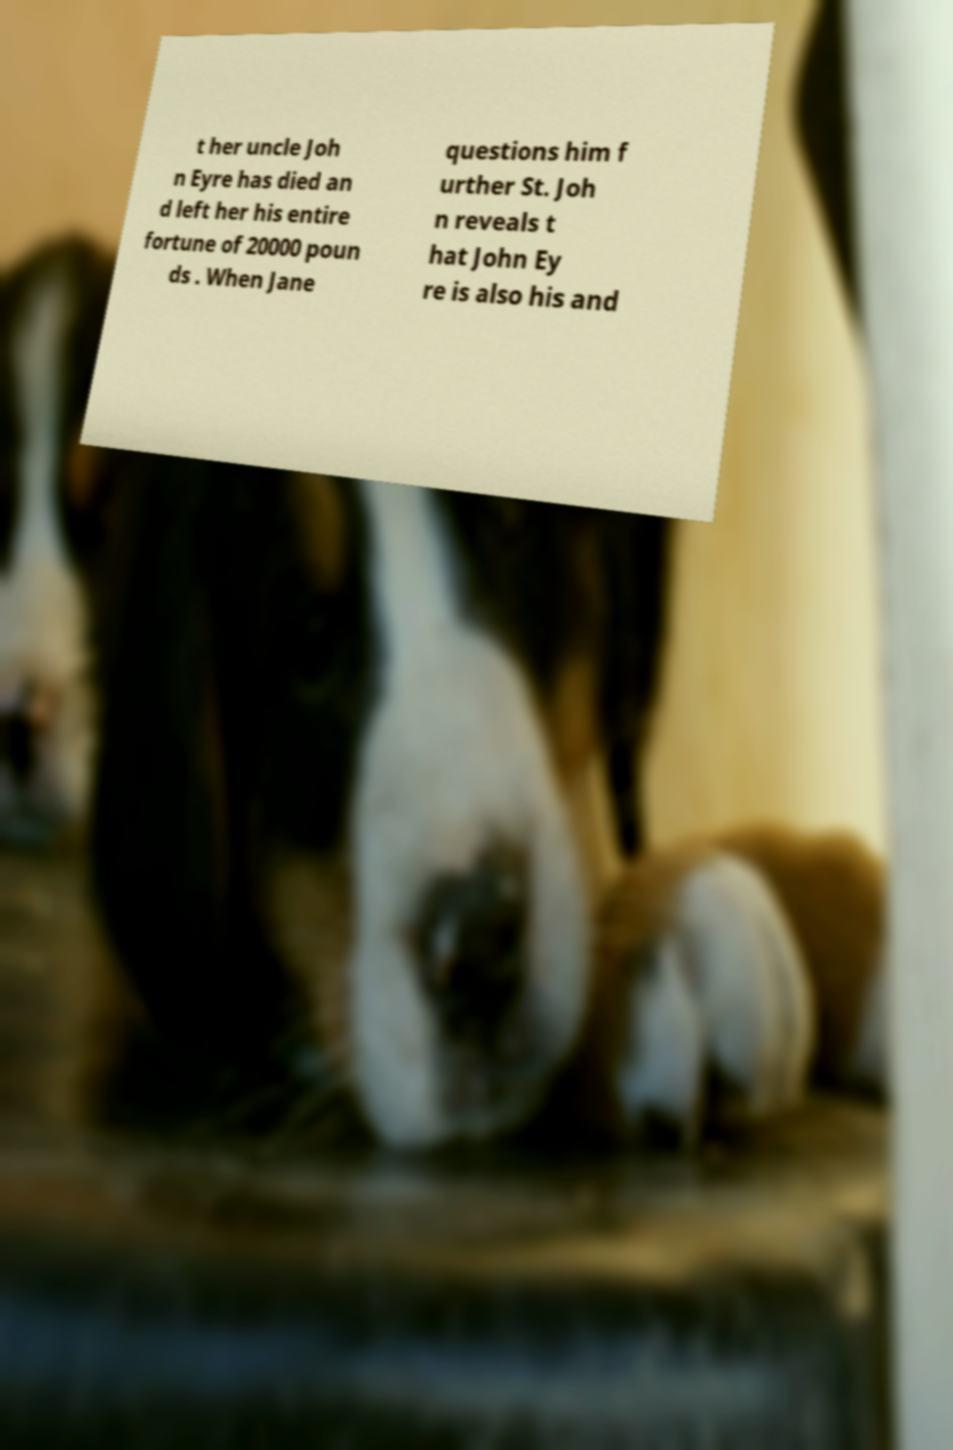I need the written content from this picture converted into text. Can you do that? t her uncle Joh n Eyre has died an d left her his entire fortune of 20000 poun ds . When Jane questions him f urther St. Joh n reveals t hat John Ey re is also his and 